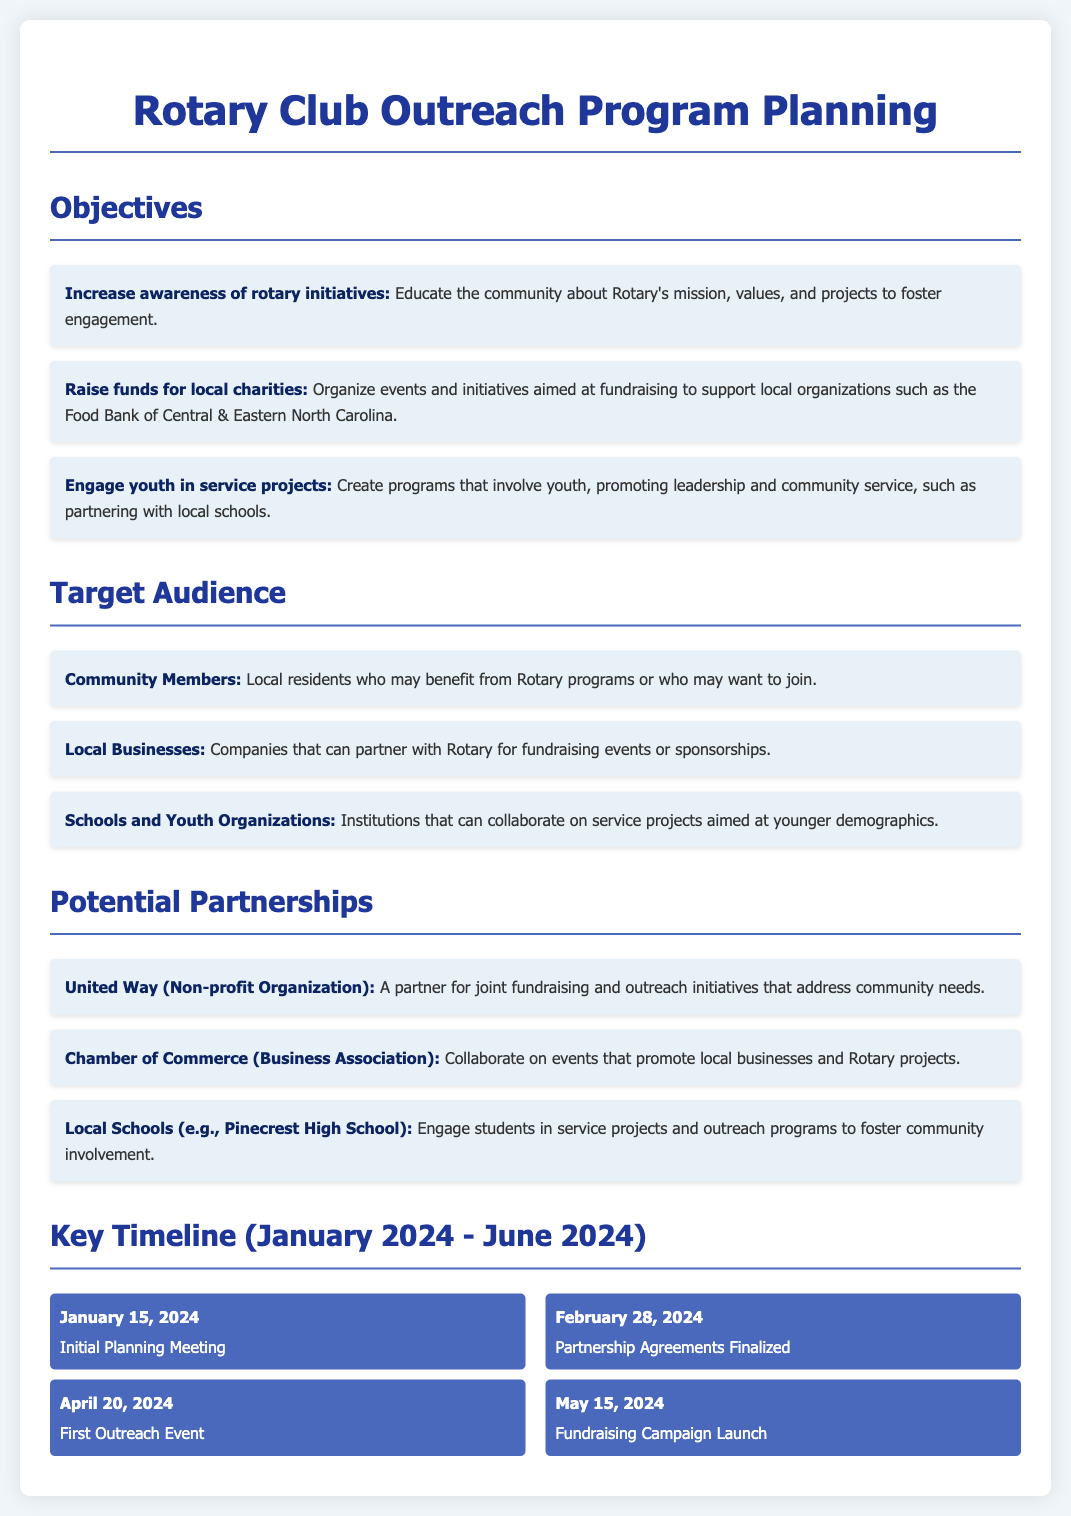What is the primary goal regarding youth? The objective mentions creating programs that involve youth, promoting leadership and community service.
Answer: Engage youth in service projects Who is the intended audience for outreach to local businesses? One of the target audience groups explicitly mentioned in the document is local businesses.
Answer: Local Businesses What is the date of the first outreach event? The timeline specifies when the first outreach event will take place.
Answer: April 20, 2024 Which organization is mentioned as a potential non-profit partner? A specific non-profit organization listed as a potential partner in the document.
Answer: United Way What date is the initial planning meeting scheduled for? The timeline indicates the specific date for the initial planning meeting.
Answer: January 15, 2024 What is the benefit to community members stated in the objectives? The objective points out educating the community about Rotary’s initiatives and projects.
Answer: Increase awareness of rotary initiatives Which entity may help in finalizing partnership agreements? The timeline lists the event related to partnerships, indicating a finalization process.
Answer: Partnership Agreements Finalized What is the purpose of engaging local schools? The document describes the intent to involve local schools in service projects.
Answer: Engage students in service projects 